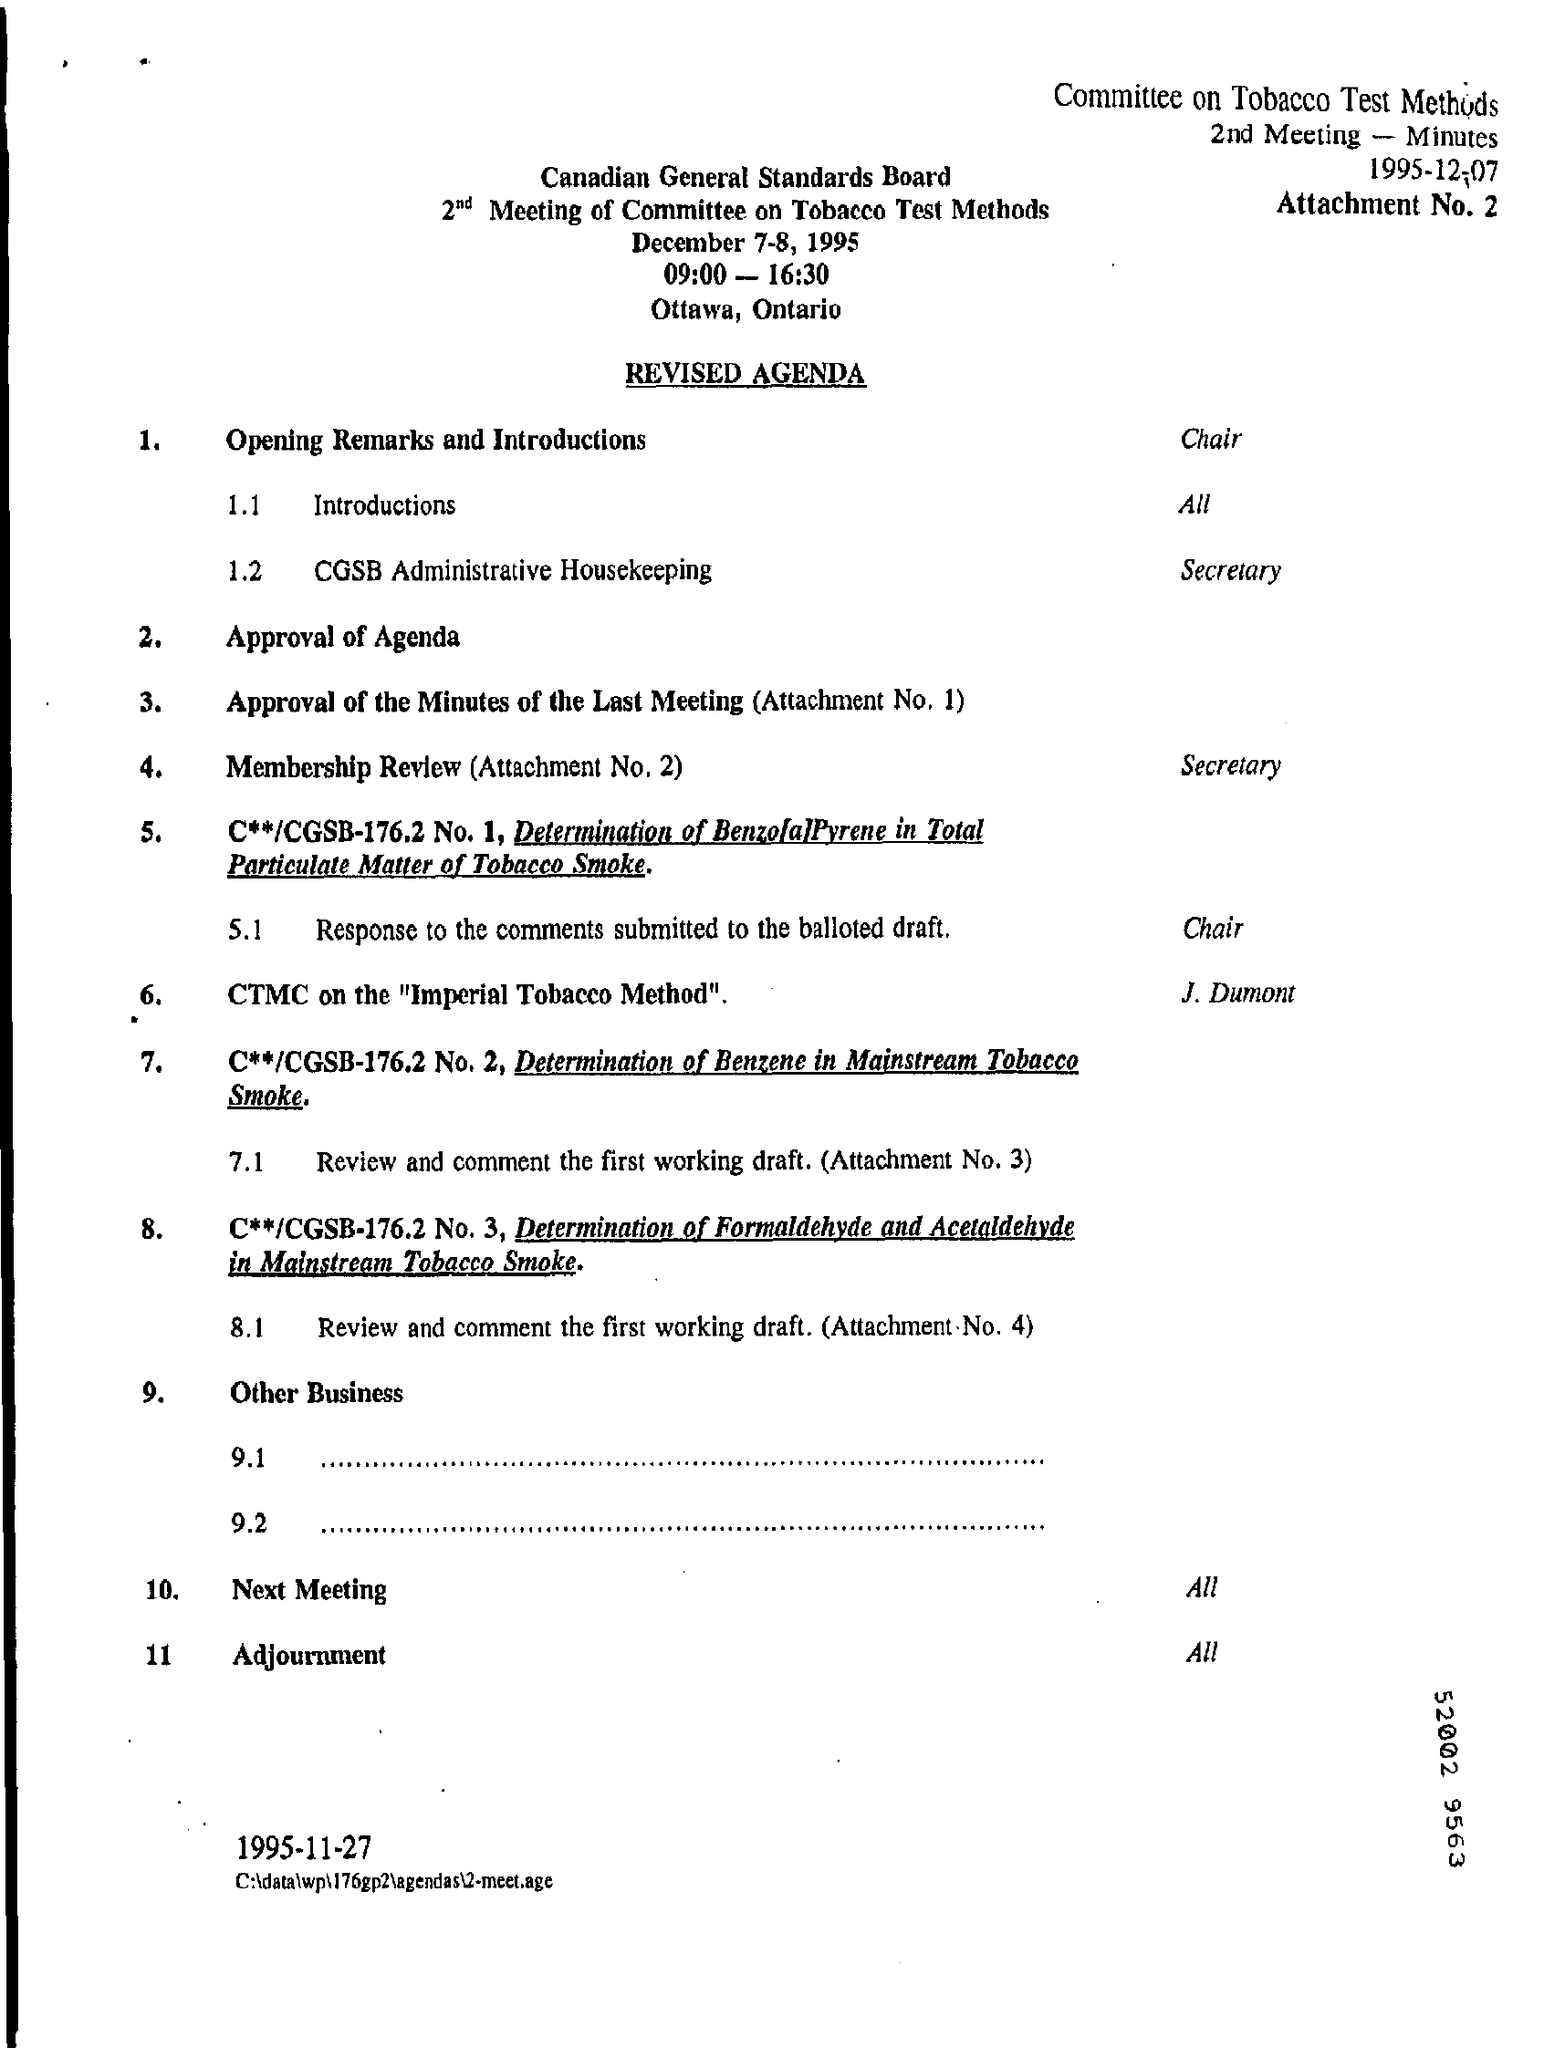List a handful of essential elements in this visual. The meeting is held in Ottawa. The Meeting was held on December 7-8, 1995. 